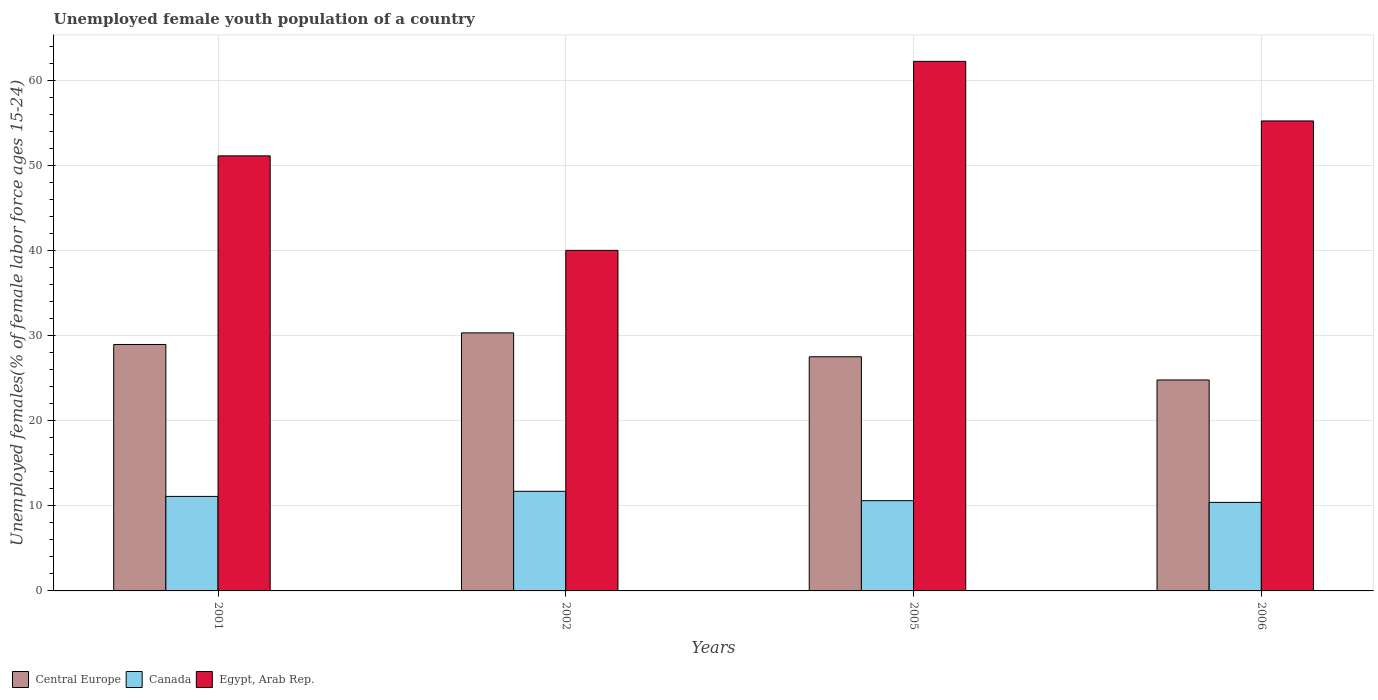How many groups of bars are there?
Keep it short and to the point. 4. What is the label of the 3rd group of bars from the left?
Your answer should be very brief. 2005. What is the percentage of unemployed female youth population in Egypt, Arab Rep. in 2001?
Keep it short and to the point. 51.1. Across all years, what is the maximum percentage of unemployed female youth population in Canada?
Provide a short and direct response. 11.7. In which year was the percentage of unemployed female youth population in Canada maximum?
Ensure brevity in your answer.  2002. In which year was the percentage of unemployed female youth population in Canada minimum?
Make the answer very short. 2006. What is the total percentage of unemployed female youth population in Central Europe in the graph?
Your response must be concise. 111.54. What is the difference between the percentage of unemployed female youth population in Central Europe in 2002 and that in 2006?
Your response must be concise. 5.53. What is the difference between the percentage of unemployed female youth population in Canada in 2005 and the percentage of unemployed female youth population in Egypt, Arab Rep. in 2001?
Ensure brevity in your answer.  -40.5. What is the average percentage of unemployed female youth population in Canada per year?
Offer a terse response. 10.95. In the year 2005, what is the difference between the percentage of unemployed female youth population in Central Europe and percentage of unemployed female youth population in Canada?
Your answer should be compact. 16.9. What is the ratio of the percentage of unemployed female youth population in Central Europe in 2002 to that in 2005?
Keep it short and to the point. 1.1. Is the percentage of unemployed female youth population in Central Europe in 2002 less than that in 2006?
Your answer should be compact. No. Is the difference between the percentage of unemployed female youth population in Central Europe in 2001 and 2006 greater than the difference between the percentage of unemployed female youth population in Canada in 2001 and 2006?
Your answer should be very brief. Yes. What is the difference between the highest and the second highest percentage of unemployed female youth population in Canada?
Provide a succinct answer. 0.6. What is the difference between the highest and the lowest percentage of unemployed female youth population in Egypt, Arab Rep.?
Your answer should be very brief. 22.2. In how many years, is the percentage of unemployed female youth population in Central Europe greater than the average percentage of unemployed female youth population in Central Europe taken over all years?
Provide a short and direct response. 2. Is the sum of the percentage of unemployed female youth population in Canada in 2002 and 2005 greater than the maximum percentage of unemployed female youth population in Central Europe across all years?
Provide a short and direct response. No. What does the 1st bar from the left in 2002 represents?
Your answer should be very brief. Central Europe. What does the 3rd bar from the right in 2005 represents?
Offer a terse response. Central Europe. Is it the case that in every year, the sum of the percentage of unemployed female youth population in Egypt, Arab Rep. and percentage of unemployed female youth population in Canada is greater than the percentage of unemployed female youth population in Central Europe?
Your response must be concise. Yes. Are all the bars in the graph horizontal?
Your response must be concise. No. What is the difference between two consecutive major ticks on the Y-axis?
Provide a short and direct response. 10. Are the values on the major ticks of Y-axis written in scientific E-notation?
Your response must be concise. No. Does the graph contain any zero values?
Offer a very short reply. No. Does the graph contain grids?
Your response must be concise. Yes. Where does the legend appear in the graph?
Offer a terse response. Bottom left. How are the legend labels stacked?
Make the answer very short. Horizontal. What is the title of the graph?
Make the answer very short. Unemployed female youth population of a country. Does "Qatar" appear as one of the legend labels in the graph?
Keep it short and to the point. No. What is the label or title of the Y-axis?
Offer a very short reply. Unemployed females(% of female labor force ages 15-24). What is the Unemployed females(% of female labor force ages 15-24) in Central Europe in 2001?
Give a very brief answer. 28.95. What is the Unemployed females(% of female labor force ages 15-24) in Canada in 2001?
Your answer should be compact. 11.1. What is the Unemployed females(% of female labor force ages 15-24) of Egypt, Arab Rep. in 2001?
Your answer should be very brief. 51.1. What is the Unemployed females(% of female labor force ages 15-24) in Central Europe in 2002?
Provide a short and direct response. 30.31. What is the Unemployed females(% of female labor force ages 15-24) in Canada in 2002?
Make the answer very short. 11.7. What is the Unemployed females(% of female labor force ages 15-24) of Central Europe in 2005?
Make the answer very short. 27.5. What is the Unemployed females(% of female labor force ages 15-24) in Canada in 2005?
Offer a terse response. 10.6. What is the Unemployed females(% of female labor force ages 15-24) of Egypt, Arab Rep. in 2005?
Give a very brief answer. 62.2. What is the Unemployed females(% of female labor force ages 15-24) of Central Europe in 2006?
Give a very brief answer. 24.78. What is the Unemployed females(% of female labor force ages 15-24) in Canada in 2006?
Ensure brevity in your answer.  10.4. What is the Unemployed females(% of female labor force ages 15-24) of Egypt, Arab Rep. in 2006?
Your response must be concise. 55.2. Across all years, what is the maximum Unemployed females(% of female labor force ages 15-24) of Central Europe?
Your response must be concise. 30.31. Across all years, what is the maximum Unemployed females(% of female labor force ages 15-24) in Canada?
Give a very brief answer. 11.7. Across all years, what is the maximum Unemployed females(% of female labor force ages 15-24) of Egypt, Arab Rep.?
Your answer should be very brief. 62.2. Across all years, what is the minimum Unemployed females(% of female labor force ages 15-24) in Central Europe?
Give a very brief answer. 24.78. Across all years, what is the minimum Unemployed females(% of female labor force ages 15-24) in Canada?
Offer a very short reply. 10.4. Across all years, what is the minimum Unemployed females(% of female labor force ages 15-24) in Egypt, Arab Rep.?
Keep it short and to the point. 40. What is the total Unemployed females(% of female labor force ages 15-24) of Central Europe in the graph?
Make the answer very short. 111.54. What is the total Unemployed females(% of female labor force ages 15-24) of Canada in the graph?
Keep it short and to the point. 43.8. What is the total Unemployed females(% of female labor force ages 15-24) in Egypt, Arab Rep. in the graph?
Provide a short and direct response. 208.5. What is the difference between the Unemployed females(% of female labor force ages 15-24) of Central Europe in 2001 and that in 2002?
Make the answer very short. -1.36. What is the difference between the Unemployed females(% of female labor force ages 15-24) of Central Europe in 2001 and that in 2005?
Ensure brevity in your answer.  1.44. What is the difference between the Unemployed females(% of female labor force ages 15-24) of Egypt, Arab Rep. in 2001 and that in 2005?
Make the answer very short. -11.1. What is the difference between the Unemployed females(% of female labor force ages 15-24) of Central Europe in 2001 and that in 2006?
Provide a short and direct response. 4.17. What is the difference between the Unemployed females(% of female labor force ages 15-24) of Egypt, Arab Rep. in 2001 and that in 2006?
Offer a terse response. -4.1. What is the difference between the Unemployed females(% of female labor force ages 15-24) of Central Europe in 2002 and that in 2005?
Provide a short and direct response. 2.81. What is the difference between the Unemployed females(% of female labor force ages 15-24) of Canada in 2002 and that in 2005?
Your response must be concise. 1.1. What is the difference between the Unemployed females(% of female labor force ages 15-24) of Egypt, Arab Rep. in 2002 and that in 2005?
Your response must be concise. -22.2. What is the difference between the Unemployed females(% of female labor force ages 15-24) of Central Europe in 2002 and that in 2006?
Provide a succinct answer. 5.53. What is the difference between the Unemployed females(% of female labor force ages 15-24) in Canada in 2002 and that in 2006?
Keep it short and to the point. 1.3. What is the difference between the Unemployed females(% of female labor force ages 15-24) in Egypt, Arab Rep. in 2002 and that in 2006?
Your answer should be very brief. -15.2. What is the difference between the Unemployed females(% of female labor force ages 15-24) in Central Europe in 2005 and that in 2006?
Your answer should be very brief. 2.73. What is the difference between the Unemployed females(% of female labor force ages 15-24) in Canada in 2005 and that in 2006?
Provide a short and direct response. 0.2. What is the difference between the Unemployed females(% of female labor force ages 15-24) of Central Europe in 2001 and the Unemployed females(% of female labor force ages 15-24) of Canada in 2002?
Keep it short and to the point. 17.25. What is the difference between the Unemployed females(% of female labor force ages 15-24) of Central Europe in 2001 and the Unemployed females(% of female labor force ages 15-24) of Egypt, Arab Rep. in 2002?
Offer a terse response. -11.05. What is the difference between the Unemployed females(% of female labor force ages 15-24) in Canada in 2001 and the Unemployed females(% of female labor force ages 15-24) in Egypt, Arab Rep. in 2002?
Make the answer very short. -28.9. What is the difference between the Unemployed females(% of female labor force ages 15-24) of Central Europe in 2001 and the Unemployed females(% of female labor force ages 15-24) of Canada in 2005?
Keep it short and to the point. 18.35. What is the difference between the Unemployed females(% of female labor force ages 15-24) of Central Europe in 2001 and the Unemployed females(% of female labor force ages 15-24) of Egypt, Arab Rep. in 2005?
Offer a terse response. -33.25. What is the difference between the Unemployed females(% of female labor force ages 15-24) in Canada in 2001 and the Unemployed females(% of female labor force ages 15-24) in Egypt, Arab Rep. in 2005?
Offer a very short reply. -51.1. What is the difference between the Unemployed females(% of female labor force ages 15-24) of Central Europe in 2001 and the Unemployed females(% of female labor force ages 15-24) of Canada in 2006?
Give a very brief answer. 18.55. What is the difference between the Unemployed females(% of female labor force ages 15-24) of Central Europe in 2001 and the Unemployed females(% of female labor force ages 15-24) of Egypt, Arab Rep. in 2006?
Keep it short and to the point. -26.25. What is the difference between the Unemployed females(% of female labor force ages 15-24) of Canada in 2001 and the Unemployed females(% of female labor force ages 15-24) of Egypt, Arab Rep. in 2006?
Ensure brevity in your answer.  -44.1. What is the difference between the Unemployed females(% of female labor force ages 15-24) of Central Europe in 2002 and the Unemployed females(% of female labor force ages 15-24) of Canada in 2005?
Offer a very short reply. 19.71. What is the difference between the Unemployed females(% of female labor force ages 15-24) in Central Europe in 2002 and the Unemployed females(% of female labor force ages 15-24) in Egypt, Arab Rep. in 2005?
Offer a terse response. -31.89. What is the difference between the Unemployed females(% of female labor force ages 15-24) in Canada in 2002 and the Unemployed females(% of female labor force ages 15-24) in Egypt, Arab Rep. in 2005?
Your answer should be compact. -50.5. What is the difference between the Unemployed females(% of female labor force ages 15-24) in Central Europe in 2002 and the Unemployed females(% of female labor force ages 15-24) in Canada in 2006?
Offer a terse response. 19.91. What is the difference between the Unemployed females(% of female labor force ages 15-24) in Central Europe in 2002 and the Unemployed females(% of female labor force ages 15-24) in Egypt, Arab Rep. in 2006?
Offer a very short reply. -24.89. What is the difference between the Unemployed females(% of female labor force ages 15-24) of Canada in 2002 and the Unemployed females(% of female labor force ages 15-24) of Egypt, Arab Rep. in 2006?
Offer a terse response. -43.5. What is the difference between the Unemployed females(% of female labor force ages 15-24) in Central Europe in 2005 and the Unemployed females(% of female labor force ages 15-24) in Canada in 2006?
Your answer should be very brief. 17.1. What is the difference between the Unemployed females(% of female labor force ages 15-24) in Central Europe in 2005 and the Unemployed females(% of female labor force ages 15-24) in Egypt, Arab Rep. in 2006?
Your answer should be compact. -27.7. What is the difference between the Unemployed females(% of female labor force ages 15-24) in Canada in 2005 and the Unemployed females(% of female labor force ages 15-24) in Egypt, Arab Rep. in 2006?
Keep it short and to the point. -44.6. What is the average Unemployed females(% of female labor force ages 15-24) of Central Europe per year?
Offer a terse response. 27.88. What is the average Unemployed females(% of female labor force ages 15-24) of Canada per year?
Provide a short and direct response. 10.95. What is the average Unemployed females(% of female labor force ages 15-24) in Egypt, Arab Rep. per year?
Ensure brevity in your answer.  52.12. In the year 2001, what is the difference between the Unemployed females(% of female labor force ages 15-24) in Central Europe and Unemployed females(% of female labor force ages 15-24) in Canada?
Your response must be concise. 17.85. In the year 2001, what is the difference between the Unemployed females(% of female labor force ages 15-24) in Central Europe and Unemployed females(% of female labor force ages 15-24) in Egypt, Arab Rep.?
Make the answer very short. -22.15. In the year 2001, what is the difference between the Unemployed females(% of female labor force ages 15-24) in Canada and Unemployed females(% of female labor force ages 15-24) in Egypt, Arab Rep.?
Your response must be concise. -40. In the year 2002, what is the difference between the Unemployed females(% of female labor force ages 15-24) of Central Europe and Unemployed females(% of female labor force ages 15-24) of Canada?
Ensure brevity in your answer.  18.61. In the year 2002, what is the difference between the Unemployed females(% of female labor force ages 15-24) in Central Europe and Unemployed females(% of female labor force ages 15-24) in Egypt, Arab Rep.?
Your response must be concise. -9.69. In the year 2002, what is the difference between the Unemployed females(% of female labor force ages 15-24) in Canada and Unemployed females(% of female labor force ages 15-24) in Egypt, Arab Rep.?
Provide a succinct answer. -28.3. In the year 2005, what is the difference between the Unemployed females(% of female labor force ages 15-24) of Central Europe and Unemployed females(% of female labor force ages 15-24) of Canada?
Your answer should be compact. 16.9. In the year 2005, what is the difference between the Unemployed females(% of female labor force ages 15-24) in Central Europe and Unemployed females(% of female labor force ages 15-24) in Egypt, Arab Rep.?
Give a very brief answer. -34.7. In the year 2005, what is the difference between the Unemployed females(% of female labor force ages 15-24) in Canada and Unemployed females(% of female labor force ages 15-24) in Egypt, Arab Rep.?
Give a very brief answer. -51.6. In the year 2006, what is the difference between the Unemployed females(% of female labor force ages 15-24) in Central Europe and Unemployed females(% of female labor force ages 15-24) in Canada?
Your answer should be compact. 14.38. In the year 2006, what is the difference between the Unemployed females(% of female labor force ages 15-24) of Central Europe and Unemployed females(% of female labor force ages 15-24) of Egypt, Arab Rep.?
Make the answer very short. -30.42. In the year 2006, what is the difference between the Unemployed females(% of female labor force ages 15-24) of Canada and Unemployed females(% of female labor force ages 15-24) of Egypt, Arab Rep.?
Your response must be concise. -44.8. What is the ratio of the Unemployed females(% of female labor force ages 15-24) of Central Europe in 2001 to that in 2002?
Your answer should be very brief. 0.95. What is the ratio of the Unemployed females(% of female labor force ages 15-24) of Canada in 2001 to that in 2002?
Make the answer very short. 0.95. What is the ratio of the Unemployed females(% of female labor force ages 15-24) of Egypt, Arab Rep. in 2001 to that in 2002?
Provide a succinct answer. 1.28. What is the ratio of the Unemployed females(% of female labor force ages 15-24) in Central Europe in 2001 to that in 2005?
Your answer should be very brief. 1.05. What is the ratio of the Unemployed females(% of female labor force ages 15-24) of Canada in 2001 to that in 2005?
Keep it short and to the point. 1.05. What is the ratio of the Unemployed females(% of female labor force ages 15-24) of Egypt, Arab Rep. in 2001 to that in 2005?
Offer a terse response. 0.82. What is the ratio of the Unemployed females(% of female labor force ages 15-24) in Central Europe in 2001 to that in 2006?
Your answer should be very brief. 1.17. What is the ratio of the Unemployed females(% of female labor force ages 15-24) of Canada in 2001 to that in 2006?
Provide a succinct answer. 1.07. What is the ratio of the Unemployed females(% of female labor force ages 15-24) of Egypt, Arab Rep. in 2001 to that in 2006?
Your answer should be compact. 0.93. What is the ratio of the Unemployed females(% of female labor force ages 15-24) in Central Europe in 2002 to that in 2005?
Offer a terse response. 1.1. What is the ratio of the Unemployed females(% of female labor force ages 15-24) of Canada in 2002 to that in 2005?
Ensure brevity in your answer.  1.1. What is the ratio of the Unemployed females(% of female labor force ages 15-24) of Egypt, Arab Rep. in 2002 to that in 2005?
Your response must be concise. 0.64. What is the ratio of the Unemployed females(% of female labor force ages 15-24) in Central Europe in 2002 to that in 2006?
Your response must be concise. 1.22. What is the ratio of the Unemployed females(% of female labor force ages 15-24) in Canada in 2002 to that in 2006?
Ensure brevity in your answer.  1.12. What is the ratio of the Unemployed females(% of female labor force ages 15-24) of Egypt, Arab Rep. in 2002 to that in 2006?
Give a very brief answer. 0.72. What is the ratio of the Unemployed females(% of female labor force ages 15-24) in Central Europe in 2005 to that in 2006?
Provide a short and direct response. 1.11. What is the ratio of the Unemployed females(% of female labor force ages 15-24) in Canada in 2005 to that in 2006?
Your answer should be very brief. 1.02. What is the ratio of the Unemployed females(% of female labor force ages 15-24) of Egypt, Arab Rep. in 2005 to that in 2006?
Give a very brief answer. 1.13. What is the difference between the highest and the second highest Unemployed females(% of female labor force ages 15-24) of Central Europe?
Make the answer very short. 1.36. What is the difference between the highest and the second highest Unemployed females(% of female labor force ages 15-24) in Egypt, Arab Rep.?
Offer a terse response. 7. What is the difference between the highest and the lowest Unemployed females(% of female labor force ages 15-24) of Central Europe?
Provide a short and direct response. 5.53. What is the difference between the highest and the lowest Unemployed females(% of female labor force ages 15-24) in Canada?
Offer a very short reply. 1.3. 